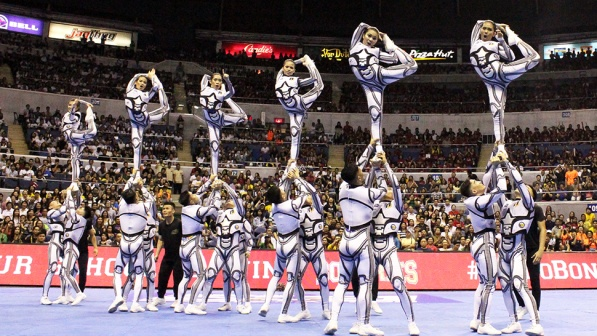How might this cheerleading event be part of a larger celebration or festival? This cheerleading event could be a highlight of a larger sports festival or cultural celebration. The event might include various performances, competitions, and community activities. Alongside the cheerleading performances, there could be parades, music concerts, and food stalls offering a variety of delicious local and international cuisines. Participants and spectators might enjoy an assortment of games, face painting, and other family-friendly activities. The entire venue would be decorated with colorful banners and balloons, creating a festive atmosphere that celebrates sportsmanship, cultural expression, and community spirit.  If these cheerleaders were superheroes, what special powers would each one have? If these cheerleaders were superheroes, each one would possess unique powers to enhance their performance and protect others. One might have the ability to fly, allowing her to perform gravity-defying stunts with ease. Another could have super strength, able to lift multiple teammates effortlessly. A third might possess the power to create force fields, ensuring the safety of her squad during complex maneuvers. Another could have superhuman agility and flexibility, executing moves with unparalleled precision. One cheerleader might have the ability to generate inspiring light shows, adding visual spectacle to their routines. Together, their powers would make them an unstoppable team, not just in cheerleading but in fighting villains and saving the day.  Tell me a short story about one of the cheerleaders in the image. Meet Maya, one of the cheerleaders in the image. From a young age, Maya dreamed of soaring to great heights, inspired by the fearless athletes she saw on TV. She trained diligently, balancing school with her rigorous practice schedule. As she grew older, her dedication paid off, and she became known for her incredible balance and agility. Now, as she stands atop the human pyramid, the crowd's cheers fuel her spirit. Maya feels an overwhelming sense of accomplishment and joy, knowing that each performance brings her closer to her dreams. Off the mat, she mentors young aspiring cheerleaders, sharing her journey and encouraging them to reach for the stars. 